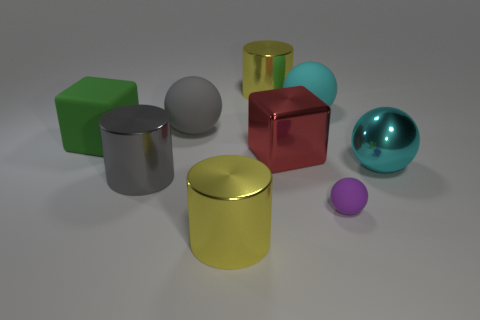What is the material of the other ball that is the same color as the large metallic ball?
Offer a very short reply. Rubber. How many rubber cubes are the same color as the small matte ball?
Your answer should be compact. 0. There is a big shiny object to the right of the shiny block; is its shape the same as the big gray rubber thing?
Make the answer very short. Yes. Is the number of cylinders in front of the cyan rubber sphere less than the number of big gray balls that are left of the green object?
Offer a very short reply. No. What is the material of the red object on the left side of the large metallic ball?
Make the answer very short. Metal. What size is the matte ball that is the same color as the big metallic sphere?
Your answer should be compact. Large. Is there a cyan metallic object that has the same size as the green cube?
Give a very brief answer. Yes. Do the large cyan matte object and the large green thing behind the big red thing have the same shape?
Offer a terse response. No. Is the size of the yellow cylinder that is behind the cyan metallic ball the same as the red shiny block that is behind the purple thing?
Provide a succinct answer. Yes. How many other things are the same shape as the large red thing?
Your response must be concise. 1. 